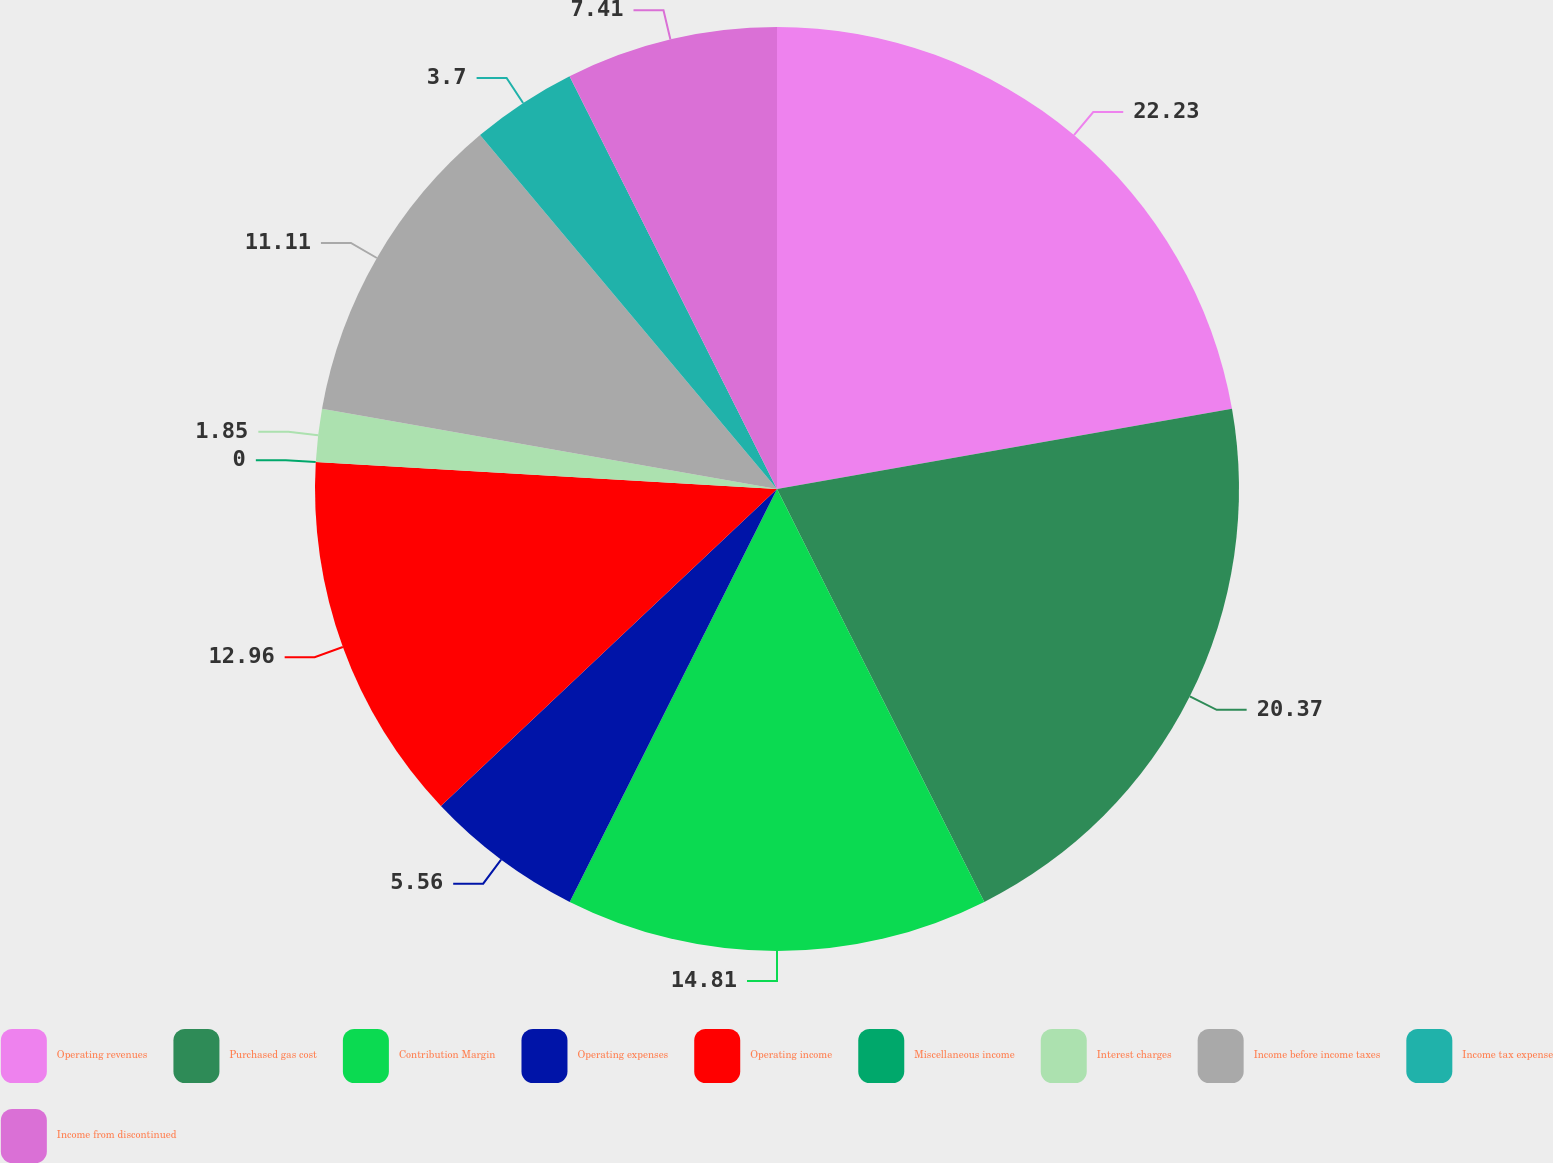Convert chart. <chart><loc_0><loc_0><loc_500><loc_500><pie_chart><fcel>Operating revenues<fcel>Purchased gas cost<fcel>Contribution Margin<fcel>Operating expenses<fcel>Operating income<fcel>Miscellaneous income<fcel>Interest charges<fcel>Income before income taxes<fcel>Income tax expense<fcel>Income from discontinued<nl><fcel>22.22%<fcel>20.37%<fcel>14.81%<fcel>5.56%<fcel>12.96%<fcel>0.0%<fcel>1.85%<fcel>11.11%<fcel>3.7%<fcel>7.41%<nl></chart> 